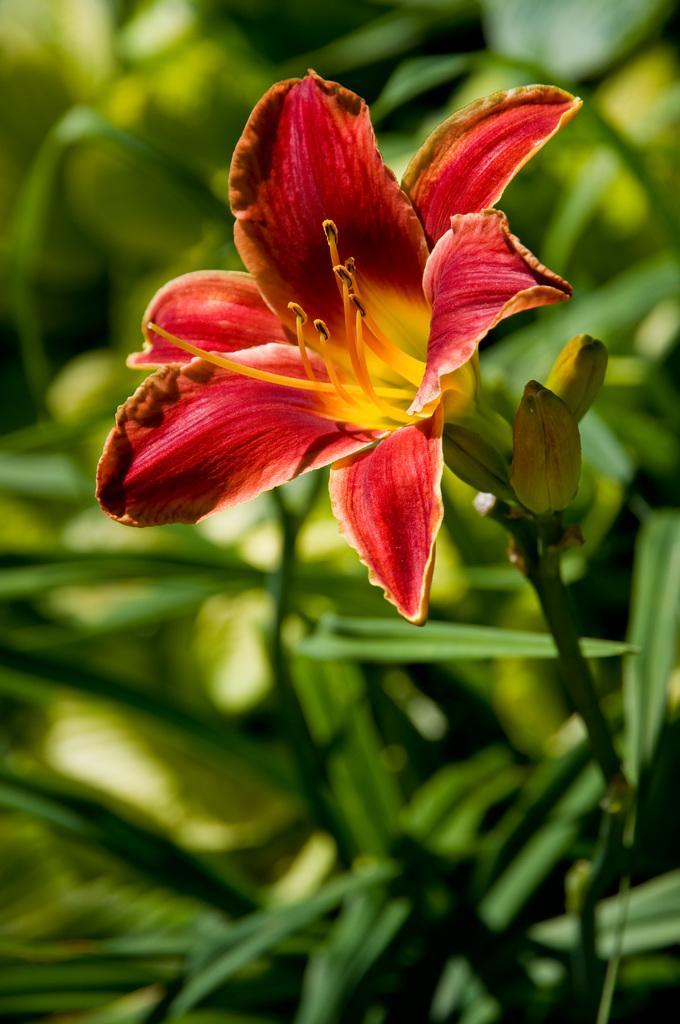In one or two sentences, can you explain what this image depicts? In this picture we can see a flower and in the background we can see leaves and it is blurry. 